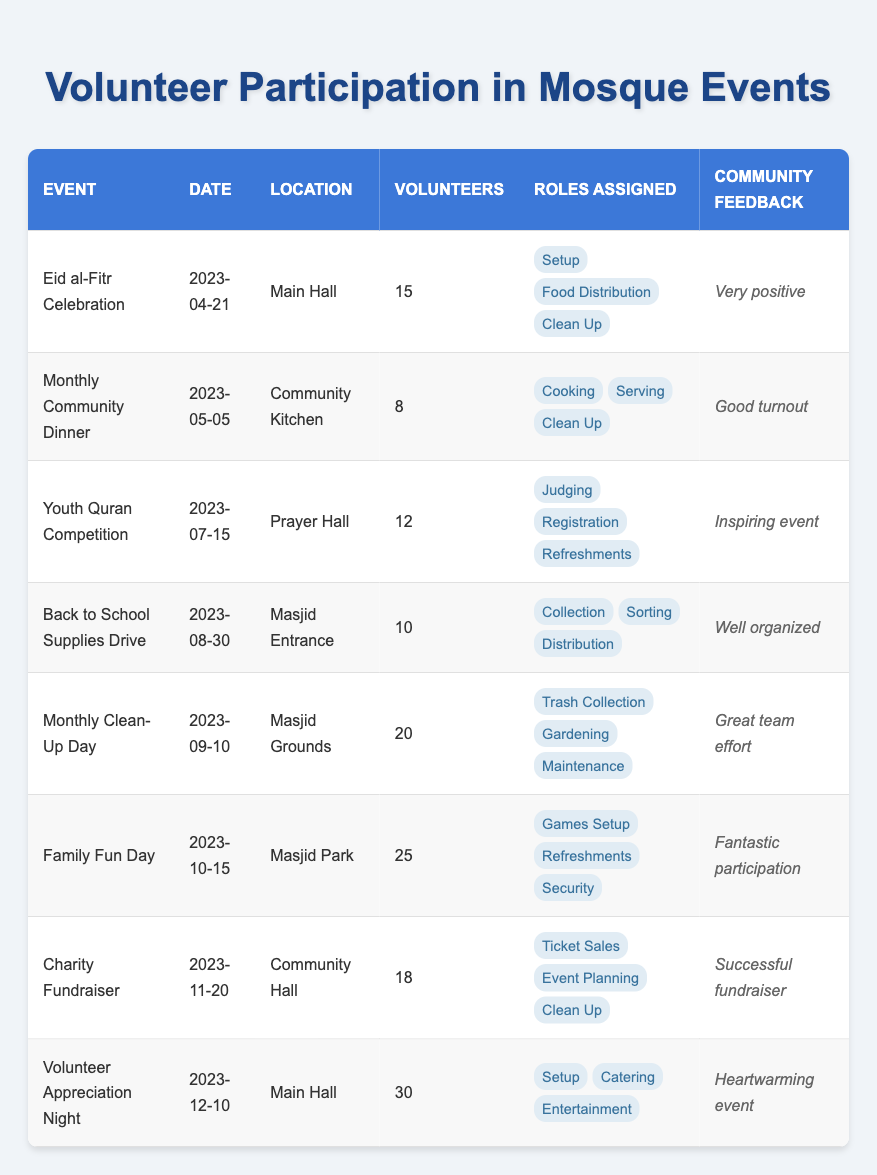What event had the highest number of volunteers? By reviewing the "Number of Volunteers" column, we find that "Volunteer Appreciation Night" had 30 volunteers, which is the highest compared to other events listed.
Answer: Volunteer Appreciation Night What roles were assigned for the Family Fun Day? Looking at the "Roles Assigned" for the "Family Fun Day" (2023-10-15), it lists "Games Setup," "Refreshments," and "Security."
Answer: Games Setup, Refreshments, Security How many volunteers participated in events located at the Main Hall? There were two events held in the Main Hall: "Eid al-Fitr Celebration" with 15 volunteers and "Volunteer Appreciation Night" with 30 volunteers. Adding these gives us 15 + 30 = 45 volunteers in total.
Answer: 45 Was community feedback for the Monthly Clean-Up Day positive? The feedback for the "Monthly Clean-Up Day" (2023-09-10) is listed as "Great team effort," indicating a positive response.
Answer: Yes What is the total number of volunteers for events held in September and October? In September, "Monthly Clean-Up Day" had 20 volunteers, and in October, "Family Fun Day" had 25 volunteers. We add these together: 20 + 25 = 45 volunteers in total.
Answer: 45 How many events received "very positive" feedback? Only one event received "very positive" feedback, which is for the "Eid al-Fitr Celebration" held on April 21. Other events received varied feedback, but only the Eid event had this specific comment.
Answer: No What was the average number of volunteers for all events? To calculate the average, we first sum the number of volunteers for all events: 15 + 8 + 12 + 10 + 20 + 25 + 18 + 30 = 138 volunteers. There are 8 events total, so the average is 138 / 8 = 17.25.
Answer: 17.25 Which event had the least number of volunteers and what was the feedback? The "Monthly Community Dinner" (2023-05-05) had the least number of volunteers, which was 8, and the community feedback for this event was "Good turnout."
Answer: Monthly Community Dinner, Good turnout 